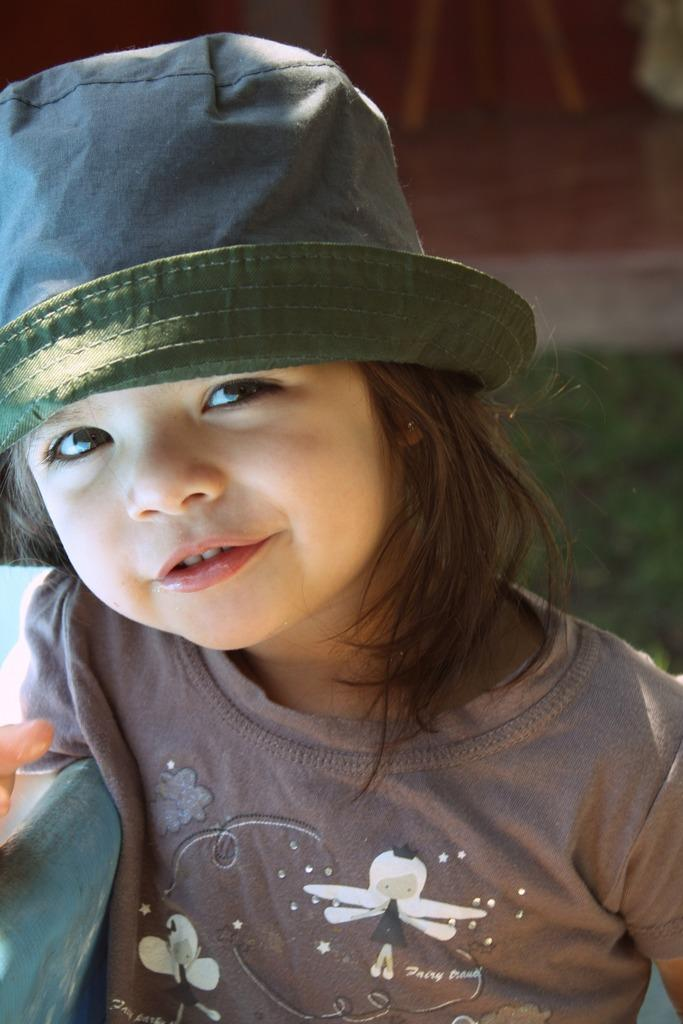Who is the main subject in the image? There is a girl in the image. What is the girl wearing on her head? The girl is wearing a hat. What type of surface is visible on the ground in the image? There is grass on the ground in the image. Can you describe the background of the image? The background of the image is slightly blurred. What type of plastic material can be seen in the image? There is no plastic material present in the image. How does the light affect the acoustics in the image? The image does not provide information about the acoustics or the effect of light on them. 